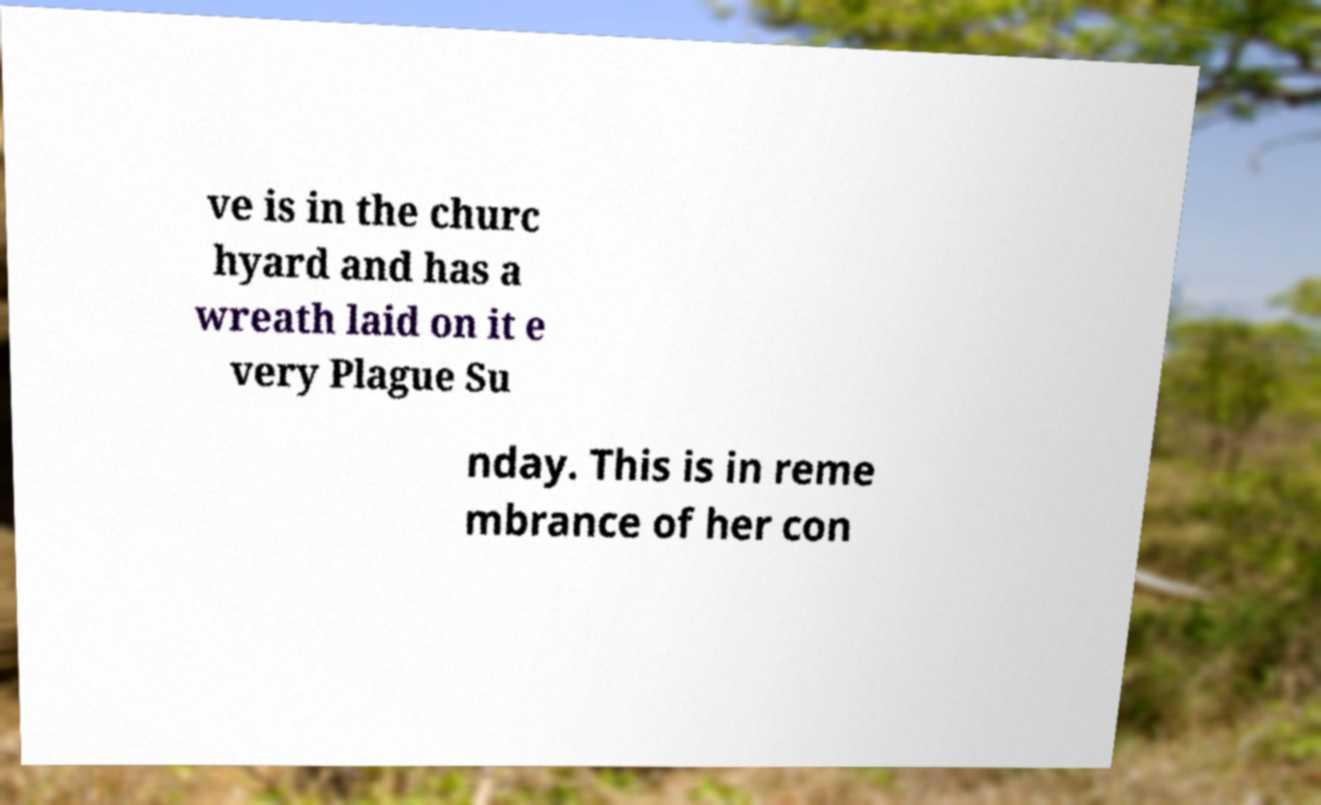Could you extract and type out the text from this image? ve is in the churc hyard and has a wreath laid on it e very Plague Su nday. This is in reme mbrance of her con 